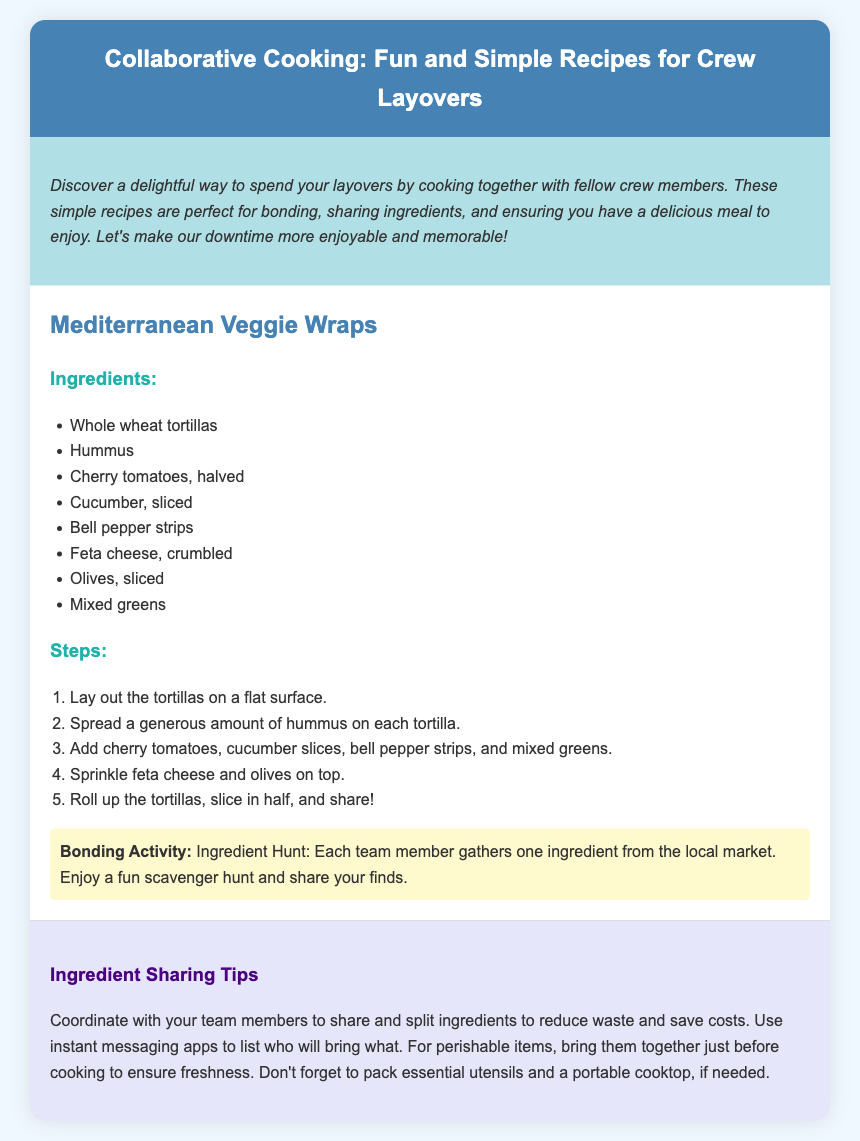what is the title of the recipe? The title of the recipe is given in the header section of the document.
Answer: Collaborative Cooking: Fun and Simple Recipes for Crew Layovers how many ingredients are listed for the Mediterranean Veggie Wraps? The number of ingredients can be counted from the ingredients list provided in the document.
Answer: 8 what is the first step in making Mediterranean Veggie Wraps? The first step can be found in the steps section of the recipe.
Answer: Lay out the tortillas on a flat surface what activity is suggested for bonding during the recipe? The bonding activity is mentioned in a specific section under the recipe.
Answer: Ingredient Hunt what are the main types of greens used in the Mediterranean Veggie Wraps? The main types of greens can be found in the ingredients section of the recipe.
Answer: Mixed greens what color is the background of the intro section? The color can be identified by visual observation from the rendered document's styling.
Answer: Light blue what should team members do to reduce waste when sharing ingredients? The recommendation for reducing waste is explained in the tips section.
Answer: Coordinate with your team members how should perishable items be handled before cooking? The guidance on handling perishable items is provided in the tips section.
Answer: Bring them together just before cooking to ensure freshness 